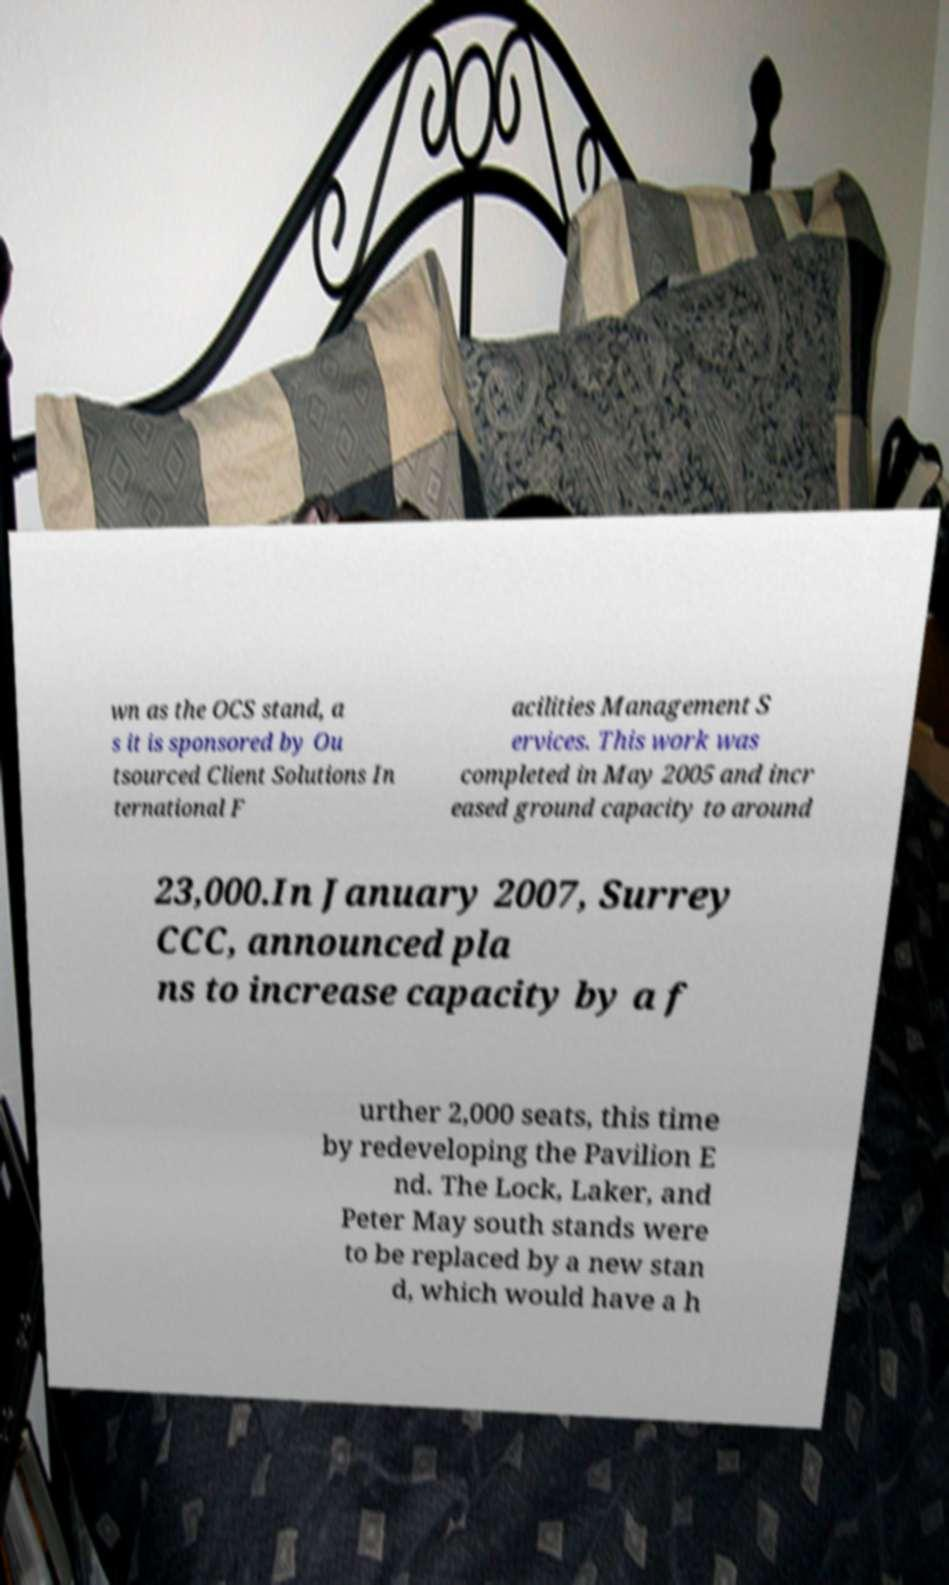There's text embedded in this image that I need extracted. Can you transcribe it verbatim? wn as the OCS stand, a s it is sponsored by Ou tsourced Client Solutions In ternational F acilities Management S ervices. This work was completed in May 2005 and incr eased ground capacity to around 23,000.In January 2007, Surrey CCC, announced pla ns to increase capacity by a f urther 2,000 seats, this time by redeveloping the Pavilion E nd. The Lock, Laker, and Peter May south stands were to be replaced by a new stan d, which would have a h 